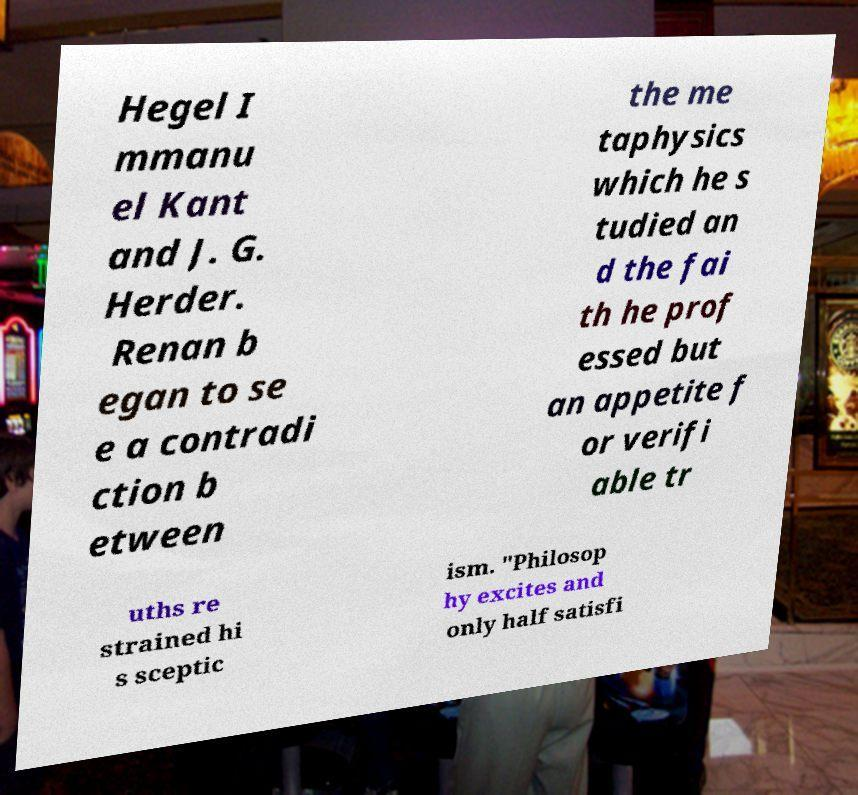Can you accurately transcribe the text from the provided image for me? Hegel I mmanu el Kant and J. G. Herder. Renan b egan to se e a contradi ction b etween the me taphysics which he s tudied an d the fai th he prof essed but an appetite f or verifi able tr uths re strained hi s sceptic ism. "Philosop hy excites and only half satisfi 